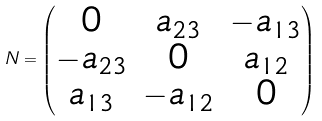<formula> <loc_0><loc_0><loc_500><loc_500>N = \begin{pmatrix} 0 & a _ { 2 3 } & - a _ { 1 3 } \\ - a _ { 2 3 } & 0 & a _ { 1 2 } \\ a _ { 1 3 } & - a _ { 1 2 } & 0 \end{pmatrix}</formula> 